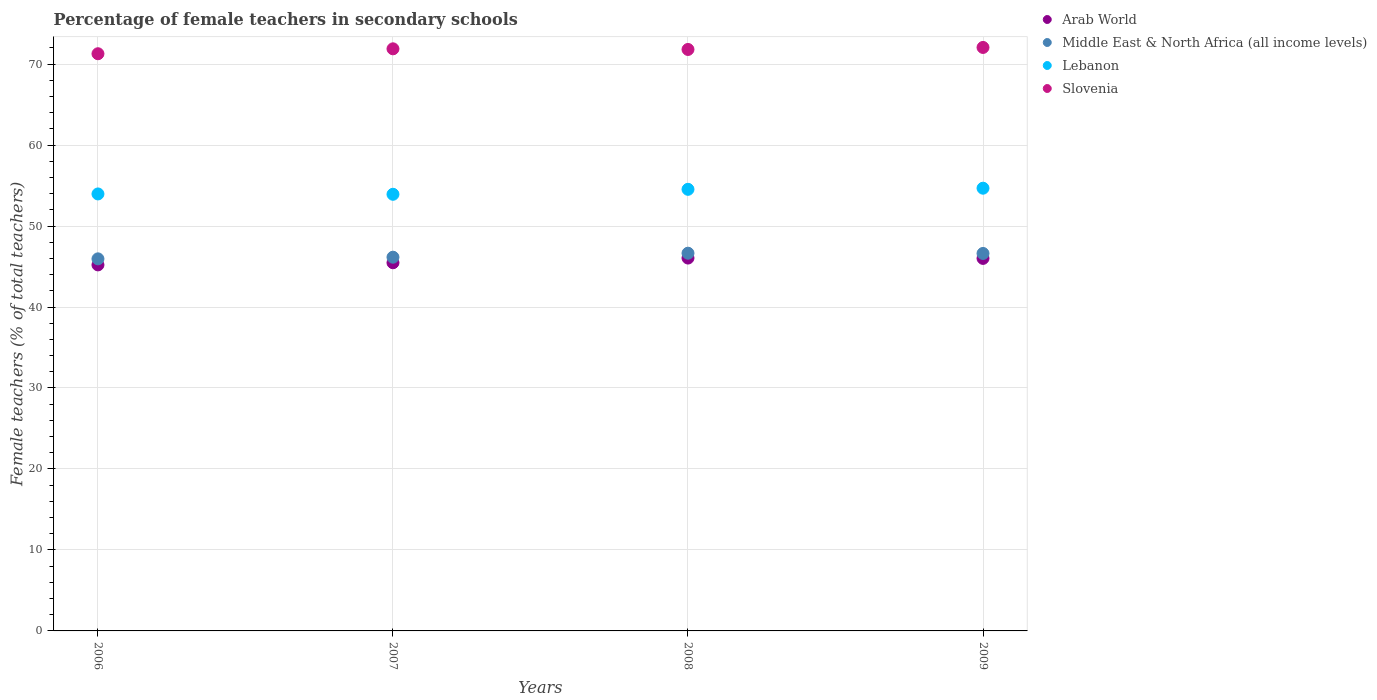How many different coloured dotlines are there?
Provide a succinct answer. 4. Is the number of dotlines equal to the number of legend labels?
Keep it short and to the point. Yes. What is the percentage of female teachers in Middle East & North Africa (all income levels) in 2007?
Give a very brief answer. 46.15. Across all years, what is the maximum percentage of female teachers in Arab World?
Ensure brevity in your answer.  46.04. Across all years, what is the minimum percentage of female teachers in Lebanon?
Your answer should be very brief. 53.92. What is the total percentage of female teachers in Lebanon in the graph?
Provide a succinct answer. 217.09. What is the difference between the percentage of female teachers in Lebanon in 2006 and that in 2007?
Offer a terse response. 0.04. What is the difference between the percentage of female teachers in Slovenia in 2009 and the percentage of female teachers in Lebanon in 2007?
Your response must be concise. 18.13. What is the average percentage of female teachers in Arab World per year?
Provide a short and direct response. 45.68. In the year 2009, what is the difference between the percentage of female teachers in Slovenia and percentage of female teachers in Middle East & North Africa (all income levels)?
Keep it short and to the point. 25.44. What is the ratio of the percentage of female teachers in Middle East & North Africa (all income levels) in 2007 to that in 2008?
Your answer should be compact. 0.99. Is the percentage of female teachers in Arab World in 2008 less than that in 2009?
Provide a short and direct response. No. Is the difference between the percentage of female teachers in Slovenia in 2008 and 2009 greater than the difference between the percentage of female teachers in Middle East & North Africa (all income levels) in 2008 and 2009?
Provide a succinct answer. No. What is the difference between the highest and the second highest percentage of female teachers in Lebanon?
Offer a terse response. 0.14. What is the difference between the highest and the lowest percentage of female teachers in Slovenia?
Your answer should be very brief. 0.78. In how many years, is the percentage of female teachers in Arab World greater than the average percentage of female teachers in Arab World taken over all years?
Offer a very short reply. 2. Is the sum of the percentage of female teachers in Slovenia in 2007 and 2009 greater than the maximum percentage of female teachers in Middle East & North Africa (all income levels) across all years?
Offer a very short reply. Yes. Is it the case that in every year, the sum of the percentage of female teachers in Middle East & North Africa (all income levels) and percentage of female teachers in Arab World  is greater than the percentage of female teachers in Lebanon?
Give a very brief answer. Yes. Does the percentage of female teachers in Arab World monotonically increase over the years?
Provide a short and direct response. No. Is the percentage of female teachers in Middle East & North Africa (all income levels) strictly greater than the percentage of female teachers in Lebanon over the years?
Offer a very short reply. No. Is the percentage of female teachers in Slovenia strictly less than the percentage of female teachers in Arab World over the years?
Give a very brief answer. No. Where does the legend appear in the graph?
Your answer should be very brief. Top right. How many legend labels are there?
Ensure brevity in your answer.  4. How are the legend labels stacked?
Your response must be concise. Vertical. What is the title of the graph?
Offer a terse response. Percentage of female teachers in secondary schools. Does "Bolivia" appear as one of the legend labels in the graph?
Your answer should be very brief. No. What is the label or title of the Y-axis?
Provide a short and direct response. Female teachers (% of total teachers). What is the Female teachers (% of total teachers) of Arab World in 2006?
Make the answer very short. 45.2. What is the Female teachers (% of total teachers) of Middle East & North Africa (all income levels) in 2006?
Give a very brief answer. 45.95. What is the Female teachers (% of total teachers) of Lebanon in 2006?
Your response must be concise. 53.96. What is the Female teachers (% of total teachers) of Slovenia in 2006?
Your response must be concise. 71.28. What is the Female teachers (% of total teachers) in Arab World in 2007?
Your answer should be very brief. 45.46. What is the Female teachers (% of total teachers) of Middle East & North Africa (all income levels) in 2007?
Offer a very short reply. 46.15. What is the Female teachers (% of total teachers) in Lebanon in 2007?
Keep it short and to the point. 53.92. What is the Female teachers (% of total teachers) in Slovenia in 2007?
Give a very brief answer. 71.88. What is the Female teachers (% of total teachers) of Arab World in 2008?
Ensure brevity in your answer.  46.04. What is the Female teachers (% of total teachers) in Middle East & North Africa (all income levels) in 2008?
Offer a very short reply. 46.65. What is the Female teachers (% of total teachers) of Lebanon in 2008?
Make the answer very short. 54.53. What is the Female teachers (% of total teachers) in Slovenia in 2008?
Ensure brevity in your answer.  71.8. What is the Female teachers (% of total teachers) in Arab World in 2009?
Offer a terse response. 46. What is the Female teachers (% of total teachers) in Middle East & North Africa (all income levels) in 2009?
Make the answer very short. 46.61. What is the Female teachers (% of total teachers) in Lebanon in 2009?
Your answer should be compact. 54.67. What is the Female teachers (% of total teachers) of Slovenia in 2009?
Make the answer very short. 72.05. Across all years, what is the maximum Female teachers (% of total teachers) of Arab World?
Keep it short and to the point. 46.04. Across all years, what is the maximum Female teachers (% of total teachers) of Middle East & North Africa (all income levels)?
Make the answer very short. 46.65. Across all years, what is the maximum Female teachers (% of total teachers) in Lebanon?
Give a very brief answer. 54.67. Across all years, what is the maximum Female teachers (% of total teachers) in Slovenia?
Your answer should be compact. 72.05. Across all years, what is the minimum Female teachers (% of total teachers) of Arab World?
Offer a terse response. 45.2. Across all years, what is the minimum Female teachers (% of total teachers) of Middle East & North Africa (all income levels)?
Your answer should be compact. 45.95. Across all years, what is the minimum Female teachers (% of total teachers) in Lebanon?
Ensure brevity in your answer.  53.92. Across all years, what is the minimum Female teachers (% of total teachers) in Slovenia?
Ensure brevity in your answer.  71.28. What is the total Female teachers (% of total teachers) of Arab World in the graph?
Provide a short and direct response. 182.71. What is the total Female teachers (% of total teachers) of Middle East & North Africa (all income levels) in the graph?
Your response must be concise. 185.36. What is the total Female teachers (% of total teachers) of Lebanon in the graph?
Provide a short and direct response. 217.09. What is the total Female teachers (% of total teachers) in Slovenia in the graph?
Offer a very short reply. 287.02. What is the difference between the Female teachers (% of total teachers) of Arab World in 2006 and that in 2007?
Make the answer very short. -0.26. What is the difference between the Female teachers (% of total teachers) in Middle East & North Africa (all income levels) in 2006 and that in 2007?
Offer a very short reply. -0.2. What is the difference between the Female teachers (% of total teachers) of Lebanon in 2006 and that in 2007?
Provide a succinct answer. 0.04. What is the difference between the Female teachers (% of total teachers) in Slovenia in 2006 and that in 2007?
Offer a terse response. -0.61. What is the difference between the Female teachers (% of total teachers) in Arab World in 2006 and that in 2008?
Your answer should be very brief. -0.84. What is the difference between the Female teachers (% of total teachers) of Middle East & North Africa (all income levels) in 2006 and that in 2008?
Give a very brief answer. -0.7. What is the difference between the Female teachers (% of total teachers) of Lebanon in 2006 and that in 2008?
Provide a short and direct response. -0.57. What is the difference between the Female teachers (% of total teachers) of Slovenia in 2006 and that in 2008?
Your answer should be very brief. -0.53. What is the difference between the Female teachers (% of total teachers) in Arab World in 2006 and that in 2009?
Your answer should be very brief. -0.8. What is the difference between the Female teachers (% of total teachers) in Middle East & North Africa (all income levels) in 2006 and that in 2009?
Your answer should be very brief. -0.67. What is the difference between the Female teachers (% of total teachers) of Lebanon in 2006 and that in 2009?
Provide a succinct answer. -0.71. What is the difference between the Female teachers (% of total teachers) in Slovenia in 2006 and that in 2009?
Provide a succinct answer. -0.78. What is the difference between the Female teachers (% of total teachers) in Arab World in 2007 and that in 2008?
Provide a short and direct response. -0.58. What is the difference between the Female teachers (% of total teachers) in Middle East & North Africa (all income levels) in 2007 and that in 2008?
Your answer should be very brief. -0.49. What is the difference between the Female teachers (% of total teachers) of Lebanon in 2007 and that in 2008?
Your answer should be very brief. -0.61. What is the difference between the Female teachers (% of total teachers) of Slovenia in 2007 and that in 2008?
Give a very brief answer. 0.08. What is the difference between the Female teachers (% of total teachers) in Arab World in 2007 and that in 2009?
Ensure brevity in your answer.  -0.54. What is the difference between the Female teachers (% of total teachers) in Middle East & North Africa (all income levels) in 2007 and that in 2009?
Offer a terse response. -0.46. What is the difference between the Female teachers (% of total teachers) in Lebanon in 2007 and that in 2009?
Give a very brief answer. -0.75. What is the difference between the Female teachers (% of total teachers) of Slovenia in 2007 and that in 2009?
Offer a terse response. -0.17. What is the difference between the Female teachers (% of total teachers) of Arab World in 2008 and that in 2009?
Provide a short and direct response. 0.04. What is the difference between the Female teachers (% of total teachers) in Middle East & North Africa (all income levels) in 2008 and that in 2009?
Provide a short and direct response. 0.03. What is the difference between the Female teachers (% of total teachers) of Lebanon in 2008 and that in 2009?
Your answer should be compact. -0.14. What is the difference between the Female teachers (% of total teachers) of Slovenia in 2008 and that in 2009?
Give a very brief answer. -0.25. What is the difference between the Female teachers (% of total teachers) of Arab World in 2006 and the Female teachers (% of total teachers) of Middle East & North Africa (all income levels) in 2007?
Give a very brief answer. -0.95. What is the difference between the Female teachers (% of total teachers) of Arab World in 2006 and the Female teachers (% of total teachers) of Lebanon in 2007?
Your answer should be very brief. -8.72. What is the difference between the Female teachers (% of total teachers) in Arab World in 2006 and the Female teachers (% of total teachers) in Slovenia in 2007?
Ensure brevity in your answer.  -26.68. What is the difference between the Female teachers (% of total teachers) of Middle East & North Africa (all income levels) in 2006 and the Female teachers (% of total teachers) of Lebanon in 2007?
Give a very brief answer. -7.97. What is the difference between the Female teachers (% of total teachers) of Middle East & North Africa (all income levels) in 2006 and the Female teachers (% of total teachers) of Slovenia in 2007?
Offer a terse response. -25.94. What is the difference between the Female teachers (% of total teachers) in Lebanon in 2006 and the Female teachers (% of total teachers) in Slovenia in 2007?
Ensure brevity in your answer.  -17.92. What is the difference between the Female teachers (% of total teachers) in Arab World in 2006 and the Female teachers (% of total teachers) in Middle East & North Africa (all income levels) in 2008?
Give a very brief answer. -1.45. What is the difference between the Female teachers (% of total teachers) of Arab World in 2006 and the Female teachers (% of total teachers) of Lebanon in 2008?
Give a very brief answer. -9.33. What is the difference between the Female teachers (% of total teachers) in Arab World in 2006 and the Female teachers (% of total teachers) in Slovenia in 2008?
Give a very brief answer. -26.6. What is the difference between the Female teachers (% of total teachers) of Middle East & North Africa (all income levels) in 2006 and the Female teachers (% of total teachers) of Lebanon in 2008?
Your answer should be compact. -8.59. What is the difference between the Female teachers (% of total teachers) in Middle East & North Africa (all income levels) in 2006 and the Female teachers (% of total teachers) in Slovenia in 2008?
Your answer should be very brief. -25.86. What is the difference between the Female teachers (% of total teachers) of Lebanon in 2006 and the Female teachers (% of total teachers) of Slovenia in 2008?
Give a very brief answer. -17.84. What is the difference between the Female teachers (% of total teachers) of Arab World in 2006 and the Female teachers (% of total teachers) of Middle East & North Africa (all income levels) in 2009?
Ensure brevity in your answer.  -1.41. What is the difference between the Female teachers (% of total teachers) in Arab World in 2006 and the Female teachers (% of total teachers) in Lebanon in 2009?
Provide a short and direct response. -9.47. What is the difference between the Female teachers (% of total teachers) in Arab World in 2006 and the Female teachers (% of total teachers) in Slovenia in 2009?
Ensure brevity in your answer.  -26.85. What is the difference between the Female teachers (% of total teachers) of Middle East & North Africa (all income levels) in 2006 and the Female teachers (% of total teachers) of Lebanon in 2009?
Ensure brevity in your answer.  -8.72. What is the difference between the Female teachers (% of total teachers) of Middle East & North Africa (all income levels) in 2006 and the Female teachers (% of total teachers) of Slovenia in 2009?
Provide a short and direct response. -26.11. What is the difference between the Female teachers (% of total teachers) in Lebanon in 2006 and the Female teachers (% of total teachers) in Slovenia in 2009?
Make the answer very short. -18.09. What is the difference between the Female teachers (% of total teachers) of Arab World in 2007 and the Female teachers (% of total teachers) of Middle East & North Africa (all income levels) in 2008?
Your response must be concise. -1.18. What is the difference between the Female teachers (% of total teachers) in Arab World in 2007 and the Female teachers (% of total teachers) in Lebanon in 2008?
Your answer should be compact. -9.07. What is the difference between the Female teachers (% of total teachers) in Arab World in 2007 and the Female teachers (% of total teachers) in Slovenia in 2008?
Provide a short and direct response. -26.34. What is the difference between the Female teachers (% of total teachers) in Middle East & North Africa (all income levels) in 2007 and the Female teachers (% of total teachers) in Lebanon in 2008?
Keep it short and to the point. -8.38. What is the difference between the Female teachers (% of total teachers) of Middle East & North Africa (all income levels) in 2007 and the Female teachers (% of total teachers) of Slovenia in 2008?
Make the answer very short. -25.65. What is the difference between the Female teachers (% of total teachers) in Lebanon in 2007 and the Female teachers (% of total teachers) in Slovenia in 2008?
Keep it short and to the point. -17.88. What is the difference between the Female teachers (% of total teachers) in Arab World in 2007 and the Female teachers (% of total teachers) in Middle East & North Africa (all income levels) in 2009?
Keep it short and to the point. -1.15. What is the difference between the Female teachers (% of total teachers) in Arab World in 2007 and the Female teachers (% of total teachers) in Lebanon in 2009?
Your response must be concise. -9.21. What is the difference between the Female teachers (% of total teachers) of Arab World in 2007 and the Female teachers (% of total teachers) of Slovenia in 2009?
Your response must be concise. -26.59. What is the difference between the Female teachers (% of total teachers) in Middle East & North Africa (all income levels) in 2007 and the Female teachers (% of total teachers) in Lebanon in 2009?
Make the answer very short. -8.52. What is the difference between the Female teachers (% of total teachers) of Middle East & North Africa (all income levels) in 2007 and the Female teachers (% of total teachers) of Slovenia in 2009?
Offer a very short reply. -25.9. What is the difference between the Female teachers (% of total teachers) in Lebanon in 2007 and the Female teachers (% of total teachers) in Slovenia in 2009?
Offer a very short reply. -18.13. What is the difference between the Female teachers (% of total teachers) of Arab World in 2008 and the Female teachers (% of total teachers) of Middle East & North Africa (all income levels) in 2009?
Offer a terse response. -0.57. What is the difference between the Female teachers (% of total teachers) in Arab World in 2008 and the Female teachers (% of total teachers) in Lebanon in 2009?
Give a very brief answer. -8.63. What is the difference between the Female teachers (% of total teachers) of Arab World in 2008 and the Female teachers (% of total teachers) of Slovenia in 2009?
Make the answer very short. -26.01. What is the difference between the Female teachers (% of total teachers) in Middle East & North Africa (all income levels) in 2008 and the Female teachers (% of total teachers) in Lebanon in 2009?
Your response must be concise. -8.03. What is the difference between the Female teachers (% of total teachers) of Middle East & North Africa (all income levels) in 2008 and the Female teachers (% of total teachers) of Slovenia in 2009?
Provide a short and direct response. -25.41. What is the difference between the Female teachers (% of total teachers) in Lebanon in 2008 and the Female teachers (% of total teachers) in Slovenia in 2009?
Offer a terse response. -17.52. What is the average Female teachers (% of total teachers) in Arab World per year?
Keep it short and to the point. 45.68. What is the average Female teachers (% of total teachers) in Middle East & North Africa (all income levels) per year?
Offer a very short reply. 46.34. What is the average Female teachers (% of total teachers) in Lebanon per year?
Ensure brevity in your answer.  54.27. What is the average Female teachers (% of total teachers) in Slovenia per year?
Offer a very short reply. 71.75. In the year 2006, what is the difference between the Female teachers (% of total teachers) of Arab World and Female teachers (% of total teachers) of Middle East & North Africa (all income levels)?
Offer a terse response. -0.75. In the year 2006, what is the difference between the Female teachers (% of total teachers) in Arab World and Female teachers (% of total teachers) in Lebanon?
Give a very brief answer. -8.76. In the year 2006, what is the difference between the Female teachers (% of total teachers) of Arab World and Female teachers (% of total teachers) of Slovenia?
Your answer should be very brief. -26.08. In the year 2006, what is the difference between the Female teachers (% of total teachers) of Middle East & North Africa (all income levels) and Female teachers (% of total teachers) of Lebanon?
Provide a succinct answer. -8.02. In the year 2006, what is the difference between the Female teachers (% of total teachers) in Middle East & North Africa (all income levels) and Female teachers (% of total teachers) in Slovenia?
Provide a succinct answer. -25.33. In the year 2006, what is the difference between the Female teachers (% of total teachers) in Lebanon and Female teachers (% of total teachers) in Slovenia?
Provide a short and direct response. -17.31. In the year 2007, what is the difference between the Female teachers (% of total teachers) of Arab World and Female teachers (% of total teachers) of Middle East & North Africa (all income levels)?
Make the answer very short. -0.69. In the year 2007, what is the difference between the Female teachers (% of total teachers) in Arab World and Female teachers (% of total teachers) in Lebanon?
Your answer should be compact. -8.46. In the year 2007, what is the difference between the Female teachers (% of total teachers) in Arab World and Female teachers (% of total teachers) in Slovenia?
Your answer should be compact. -26.42. In the year 2007, what is the difference between the Female teachers (% of total teachers) in Middle East & North Africa (all income levels) and Female teachers (% of total teachers) in Lebanon?
Keep it short and to the point. -7.77. In the year 2007, what is the difference between the Female teachers (% of total teachers) of Middle East & North Africa (all income levels) and Female teachers (% of total teachers) of Slovenia?
Offer a terse response. -25.73. In the year 2007, what is the difference between the Female teachers (% of total teachers) of Lebanon and Female teachers (% of total teachers) of Slovenia?
Offer a very short reply. -17.96. In the year 2008, what is the difference between the Female teachers (% of total teachers) of Arab World and Female teachers (% of total teachers) of Middle East & North Africa (all income levels)?
Provide a succinct answer. -0.6. In the year 2008, what is the difference between the Female teachers (% of total teachers) in Arab World and Female teachers (% of total teachers) in Lebanon?
Make the answer very short. -8.49. In the year 2008, what is the difference between the Female teachers (% of total teachers) of Arab World and Female teachers (% of total teachers) of Slovenia?
Keep it short and to the point. -25.76. In the year 2008, what is the difference between the Female teachers (% of total teachers) in Middle East & North Africa (all income levels) and Female teachers (% of total teachers) in Lebanon?
Offer a terse response. -7.89. In the year 2008, what is the difference between the Female teachers (% of total teachers) in Middle East & North Africa (all income levels) and Female teachers (% of total teachers) in Slovenia?
Keep it short and to the point. -25.16. In the year 2008, what is the difference between the Female teachers (% of total teachers) in Lebanon and Female teachers (% of total teachers) in Slovenia?
Provide a succinct answer. -17.27. In the year 2009, what is the difference between the Female teachers (% of total teachers) in Arab World and Female teachers (% of total teachers) in Middle East & North Africa (all income levels)?
Ensure brevity in your answer.  -0.61. In the year 2009, what is the difference between the Female teachers (% of total teachers) in Arab World and Female teachers (% of total teachers) in Lebanon?
Keep it short and to the point. -8.67. In the year 2009, what is the difference between the Female teachers (% of total teachers) of Arab World and Female teachers (% of total teachers) of Slovenia?
Provide a short and direct response. -26.05. In the year 2009, what is the difference between the Female teachers (% of total teachers) in Middle East & North Africa (all income levels) and Female teachers (% of total teachers) in Lebanon?
Offer a very short reply. -8.06. In the year 2009, what is the difference between the Female teachers (% of total teachers) of Middle East & North Africa (all income levels) and Female teachers (% of total teachers) of Slovenia?
Give a very brief answer. -25.44. In the year 2009, what is the difference between the Female teachers (% of total teachers) of Lebanon and Female teachers (% of total teachers) of Slovenia?
Give a very brief answer. -17.38. What is the ratio of the Female teachers (% of total teachers) in Middle East & North Africa (all income levels) in 2006 to that in 2007?
Offer a terse response. 1. What is the ratio of the Female teachers (% of total teachers) of Arab World in 2006 to that in 2008?
Provide a succinct answer. 0.98. What is the ratio of the Female teachers (% of total teachers) in Middle East & North Africa (all income levels) in 2006 to that in 2008?
Keep it short and to the point. 0.98. What is the ratio of the Female teachers (% of total teachers) in Arab World in 2006 to that in 2009?
Give a very brief answer. 0.98. What is the ratio of the Female teachers (% of total teachers) of Middle East & North Africa (all income levels) in 2006 to that in 2009?
Ensure brevity in your answer.  0.99. What is the ratio of the Female teachers (% of total teachers) in Lebanon in 2006 to that in 2009?
Provide a succinct answer. 0.99. What is the ratio of the Female teachers (% of total teachers) in Slovenia in 2006 to that in 2009?
Provide a short and direct response. 0.99. What is the ratio of the Female teachers (% of total teachers) in Arab World in 2007 to that in 2008?
Provide a succinct answer. 0.99. What is the ratio of the Female teachers (% of total teachers) in Middle East & North Africa (all income levels) in 2007 to that in 2008?
Your answer should be compact. 0.99. What is the ratio of the Female teachers (% of total teachers) in Slovenia in 2007 to that in 2008?
Ensure brevity in your answer.  1. What is the ratio of the Female teachers (% of total teachers) in Arab World in 2007 to that in 2009?
Your answer should be compact. 0.99. What is the ratio of the Female teachers (% of total teachers) in Middle East & North Africa (all income levels) in 2007 to that in 2009?
Offer a terse response. 0.99. What is the ratio of the Female teachers (% of total teachers) of Lebanon in 2007 to that in 2009?
Provide a short and direct response. 0.99. What is the ratio of the Female teachers (% of total teachers) of Slovenia in 2007 to that in 2009?
Provide a succinct answer. 1. What is the ratio of the Female teachers (% of total teachers) in Arab World in 2008 to that in 2009?
Ensure brevity in your answer.  1. What is the ratio of the Female teachers (% of total teachers) of Middle East & North Africa (all income levels) in 2008 to that in 2009?
Provide a short and direct response. 1. What is the ratio of the Female teachers (% of total teachers) of Lebanon in 2008 to that in 2009?
Your answer should be compact. 1. What is the difference between the highest and the second highest Female teachers (% of total teachers) of Arab World?
Ensure brevity in your answer.  0.04. What is the difference between the highest and the second highest Female teachers (% of total teachers) of Middle East & North Africa (all income levels)?
Your response must be concise. 0.03. What is the difference between the highest and the second highest Female teachers (% of total teachers) of Lebanon?
Offer a terse response. 0.14. What is the difference between the highest and the second highest Female teachers (% of total teachers) of Slovenia?
Provide a short and direct response. 0.17. What is the difference between the highest and the lowest Female teachers (% of total teachers) of Arab World?
Ensure brevity in your answer.  0.84. What is the difference between the highest and the lowest Female teachers (% of total teachers) of Middle East & North Africa (all income levels)?
Offer a very short reply. 0.7. What is the difference between the highest and the lowest Female teachers (% of total teachers) of Lebanon?
Provide a short and direct response. 0.75. What is the difference between the highest and the lowest Female teachers (% of total teachers) of Slovenia?
Offer a very short reply. 0.78. 